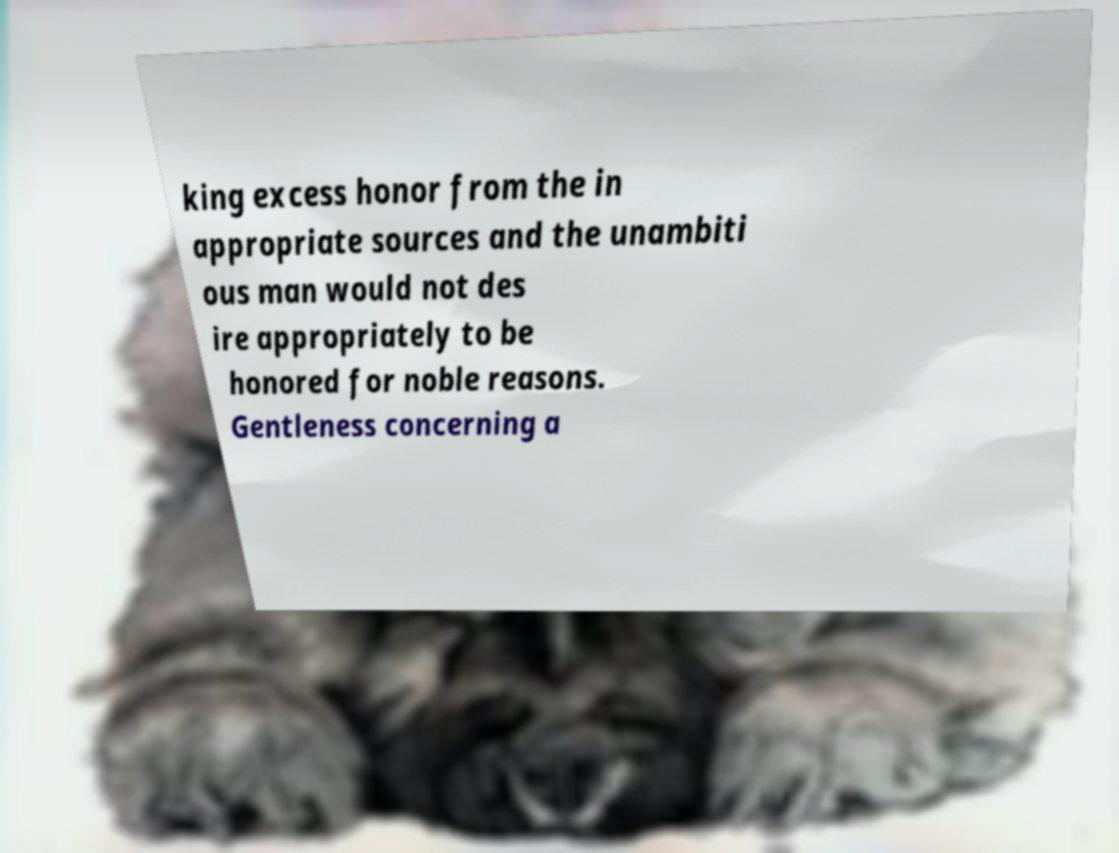Please read and relay the text visible in this image. What does it say? king excess honor from the in appropriate sources and the unambiti ous man would not des ire appropriately to be honored for noble reasons. Gentleness concerning a 